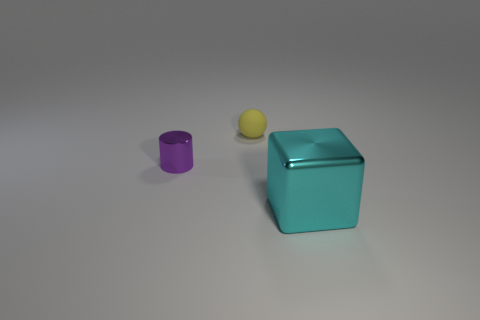Add 1 large cyan metal spheres. How many objects exist? 4 Subtract all cylinders. How many objects are left? 2 Subtract all yellow rubber balls. Subtract all small cylinders. How many objects are left? 1 Add 1 purple metal things. How many purple metal things are left? 2 Add 1 cyan matte cylinders. How many cyan matte cylinders exist? 1 Subtract 0 gray balls. How many objects are left? 3 